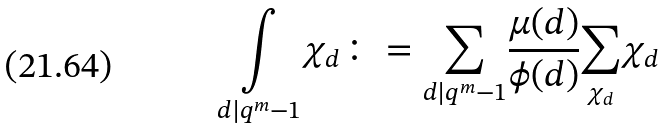Convert formula to latex. <formula><loc_0><loc_0><loc_500><loc_500>\underset { d | q ^ { m } - 1 } { \int } \chi _ { d } \colon = \underset { d | q ^ { m } - 1 } { \sum } \frac { \mu ( d ) } { \phi ( d ) } \underset { \chi _ { d } } { \sum } \chi _ { d }</formula> 